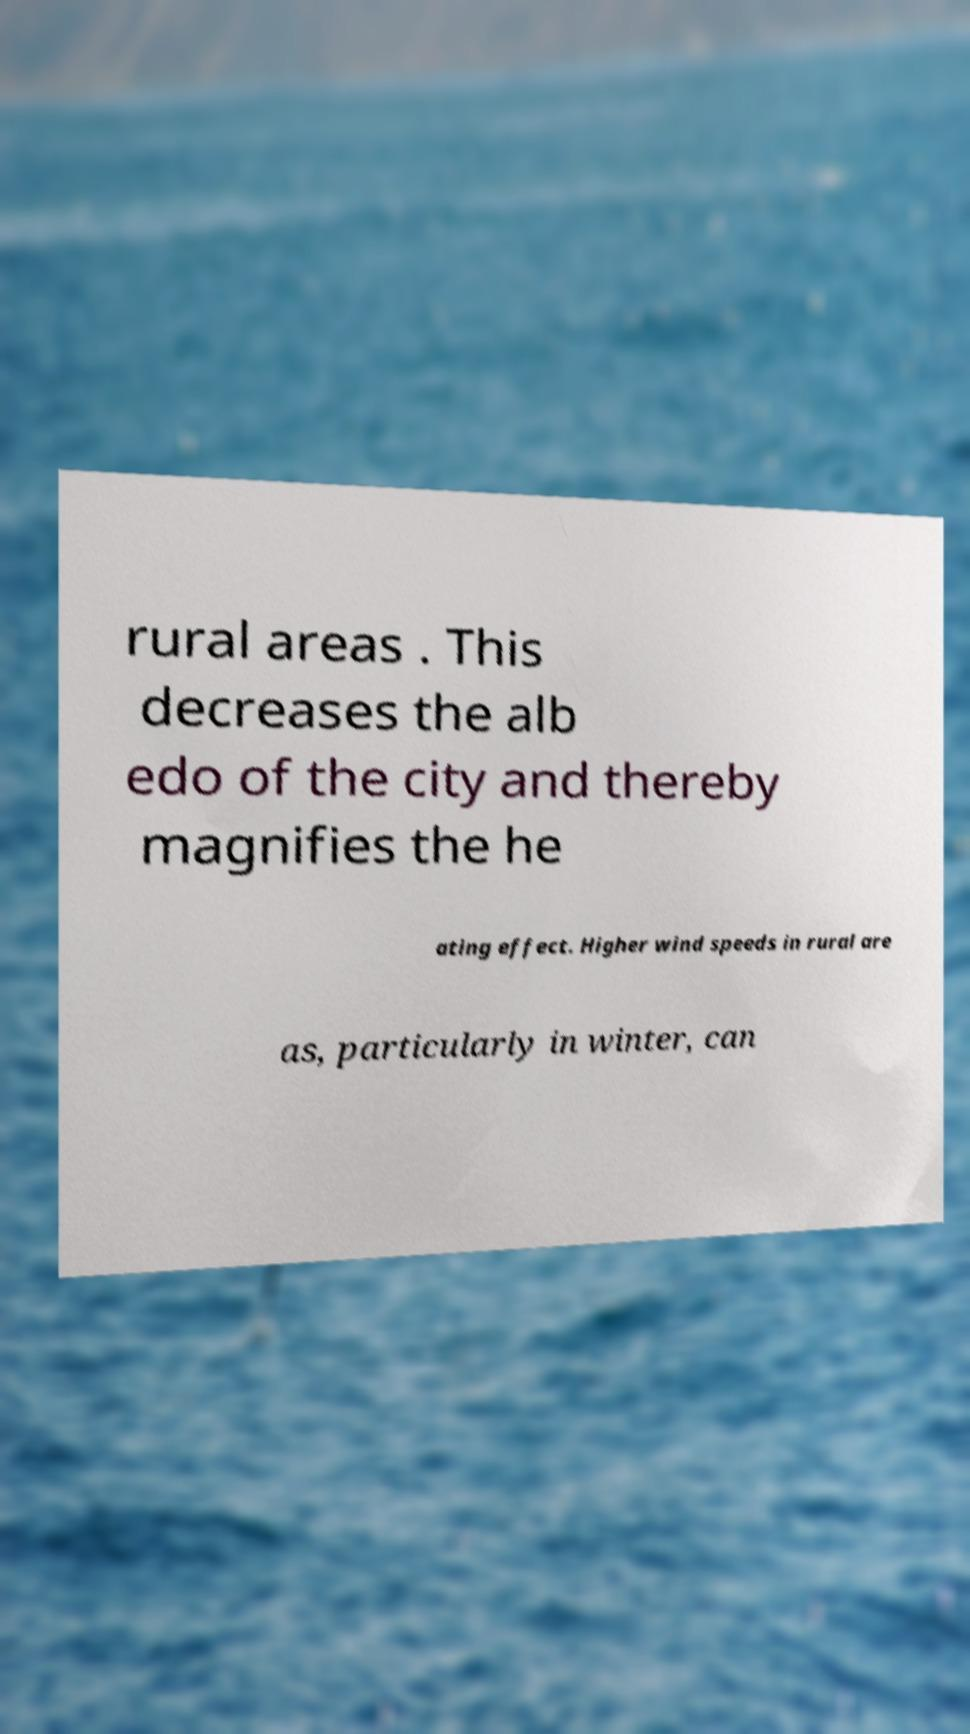For documentation purposes, I need the text within this image transcribed. Could you provide that? rural areas . This decreases the alb edo of the city and thereby magnifies the he ating effect. Higher wind speeds in rural are as, particularly in winter, can 